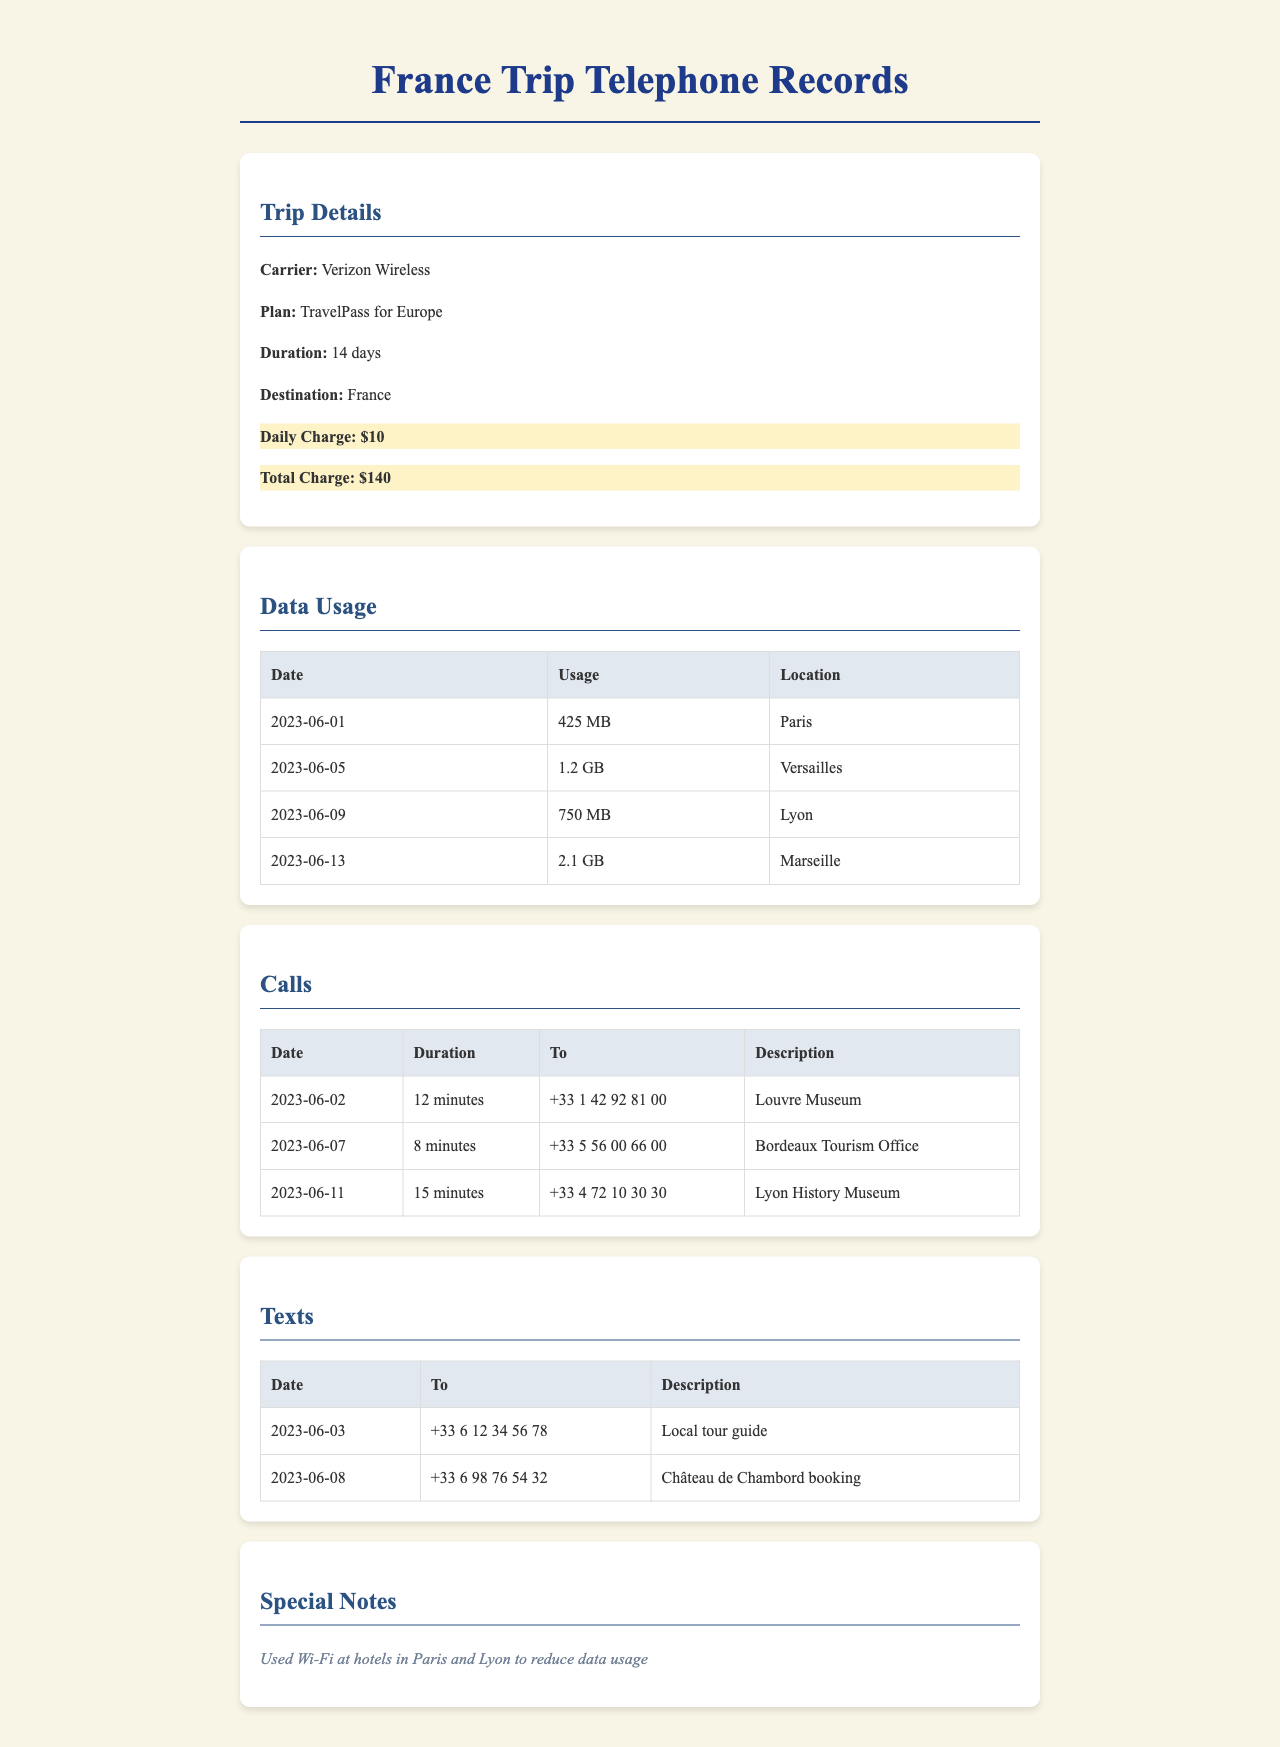What was the daily charge for the TravelPass? The daily charge is listed under the trip details section, which shows that it is $10 per day.
Answer: $10 What was the total charge for the trip to France? The total charge represents the entire fee incurred for the duration of the trip and is noted as $140.
Answer: $140 What was the location on June 5, 2023, when the data usage was recorded? The data usage table indicates that 1.2 GB was used in Versailles on June 5, 2023.
Answer: Versailles How many minutes was the call made to the Bordeaux Tourism Office? The call details indicate that the call duration to the Bordeaux Tourism Office was 8 minutes on June 7, 2023.
Answer: 8 minutes Which location had the highest data usage? The data usage table shows that 2.1 GB was used in Marseille, making it the highest usage.
Answer: Marseille What type of plan was used during the trip? The trip details mention that the plan used was TravelPass for Europe.
Answer: TravelPass for Europe On what date was the text sent to the local tour guide? The texts section lists that a message was sent on June 3, 2023, to the local tour guide.
Answer: June 3, 2023 How many total calls are listed in the document? The calls table includes a total of three calls made during the trip.
Answer: 3 What special note is mentioned regarding data usage? A note states that Wi-Fi was used at hotels in Paris and Lyon to reduce data usage.
Answer: Used Wi-Fi at hotels in Paris and Lyon to reduce data usage 